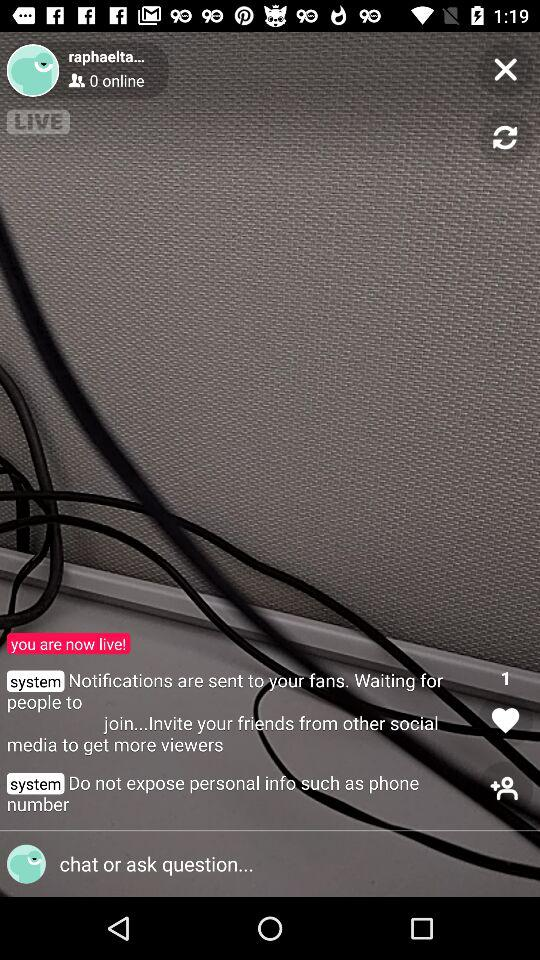What is the purpose of this interface? This interface appears to belong to a live streaming platform, designed to inform the user that they are currently broadcasting live and to convey key information such as viewer count, notifications for new joiners, and reminders for privacy protection. 